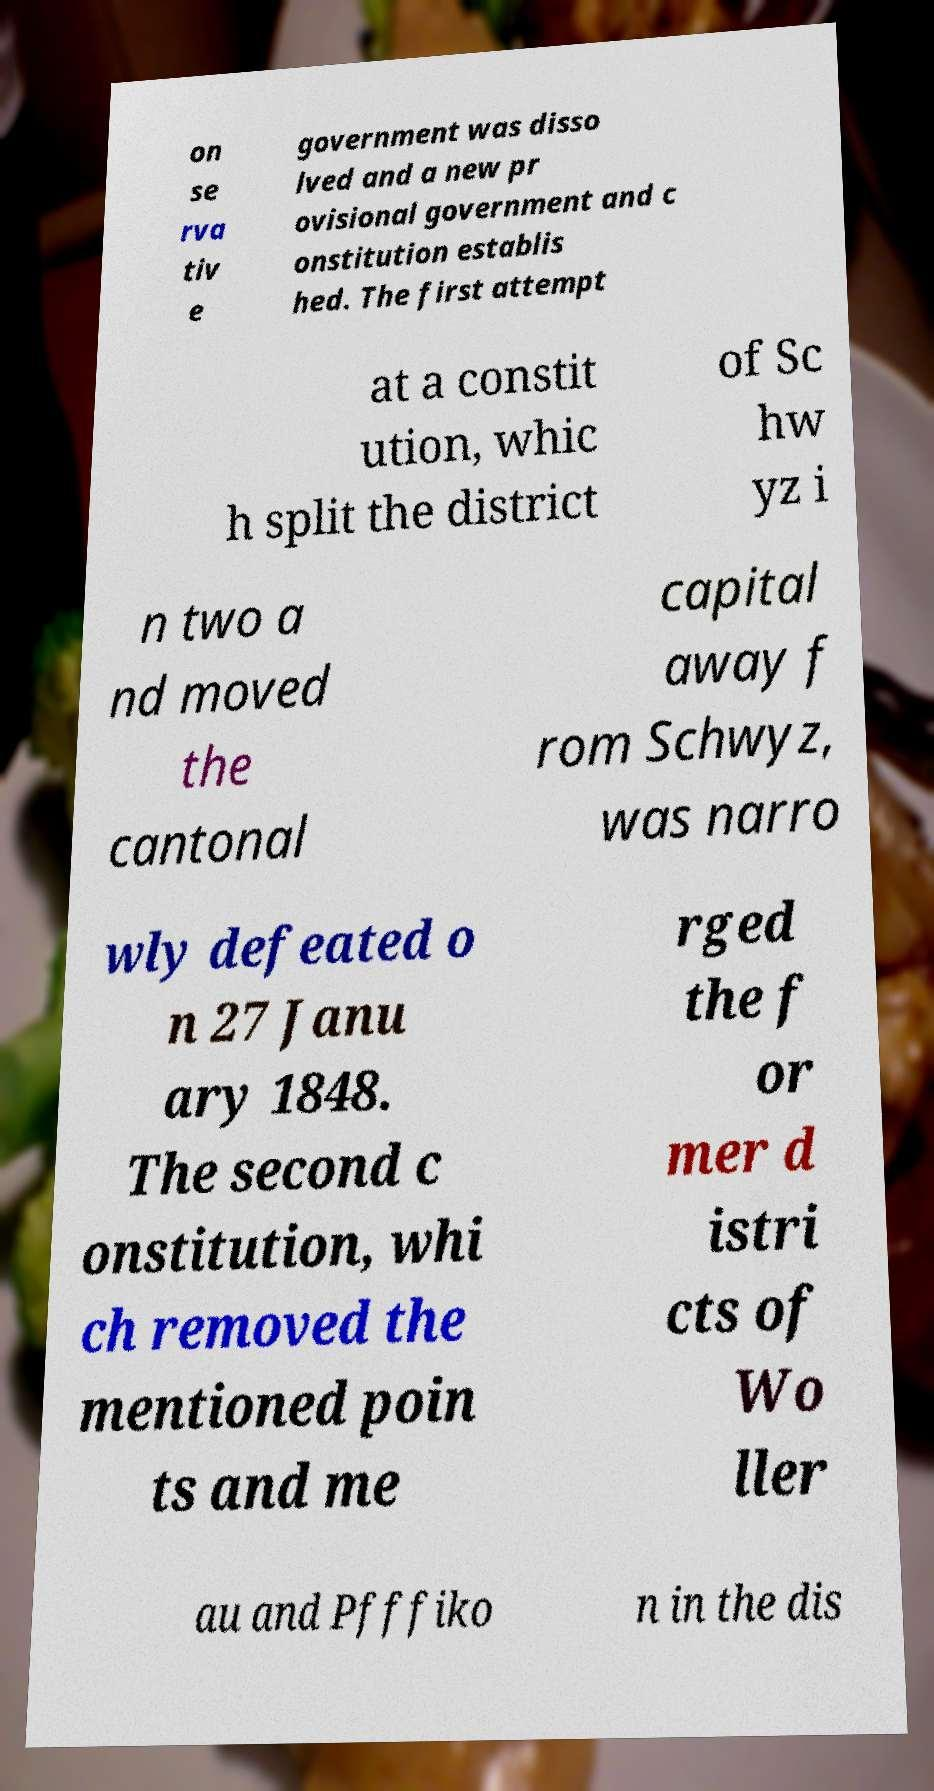Please identify and transcribe the text found in this image. on se rva tiv e government was disso lved and a new pr ovisional government and c onstitution establis hed. The first attempt at a constit ution, whic h split the district of Sc hw yz i n two a nd moved the cantonal capital away f rom Schwyz, was narro wly defeated o n 27 Janu ary 1848. The second c onstitution, whi ch removed the mentioned poin ts and me rged the f or mer d istri cts of Wo ller au and Pfffiko n in the dis 